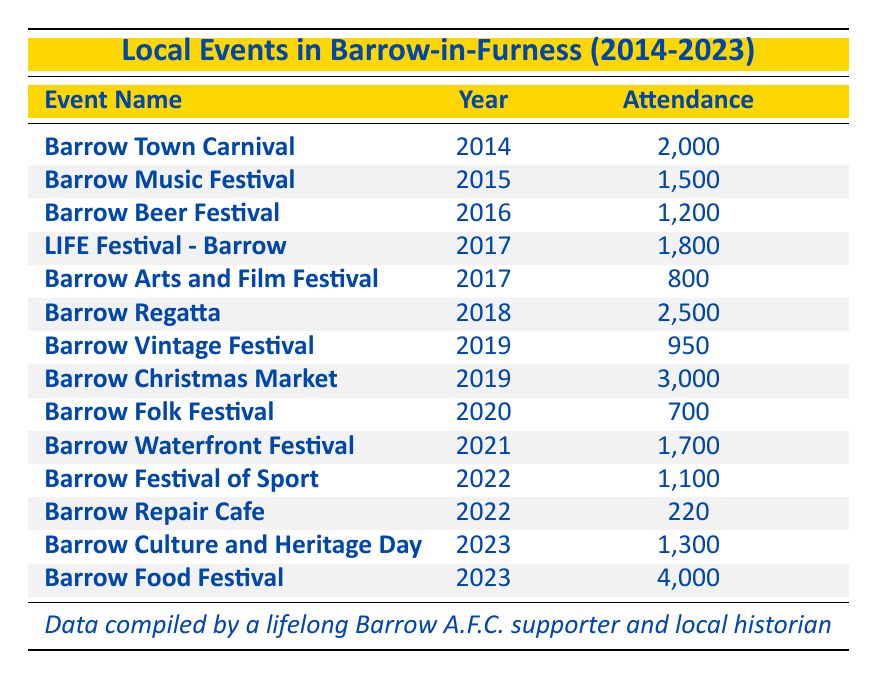What was the attendance of the Barrow Regatta in 2018? The table shows that the attendance for the Barrow Regatta, which took place in 2018, was 2,500.
Answer: 2,500 Which event had the highest attendance in 2023? According to the table, the Barrow Food Festival, with an attendance of 4,000, had the highest attendance in 2023.
Answer: Barrow Food Festival What is the total attendance for events held in 2017? Adding the attendance for events in 2017: LIFE Festival (1,800) + Barrow Arts and Film Festival (800) = 2,600.
Answer: 2,600 Is the attendance for the Barrow Christmas Market greater than 2,500? The attendance for the Barrow Christmas Market in 2019 is listed as 3,000, which is indeed greater than 2,500.
Answer: Yes How many events had an attendance of over 1,500? From the table, we can count: Barrow Town Carnival (2,000), Barrow Regatta (2,500), Barrow Christmas Market (3,000), and Barrow Food Festival (4,000). Therefore, there are 4 events with attendance over 1,500.
Answer: 4 What was the average attendance for events held in 2022? For 2022, there are two events: Barrow Festival of Sport (1,100) and Barrow Repair Cafe (220). The total attendance is 1,100 + 220 = 1,320. The average is 1,320 / 2 = 660.
Answer: 660 Which event had the lowest attendance in Barrow in the last decade? Reviewing the table, the Barrow Repair Cafe in 2022 had the lowest attendance of 220.
Answer: Barrow Repair Cafe What is the difference in attendance between the Barrow Music Festival and the Barrow Folk Festival? The attendance for the Barrow Music Festival is 1,500, and for the Barrow Folk Festival, it is 700. The difference is 1,500 - 700 = 800.
Answer: 800 How many years had events with attendance below 1,000? From the table, the years with events below 1,000 are 2017 (Barrow Arts and Film Festival, 800), 2019 (Barrow Vintage Festival, 950), and 2022 (Barrow Repair Cafe, 220), totaling three years.
Answer: 3 